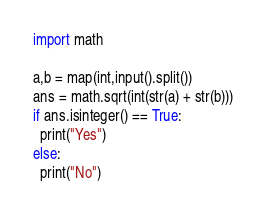<code> <loc_0><loc_0><loc_500><loc_500><_Python_>import math 

a,b = map(int,input().split())
ans = math.sqrt(int(str(a) + str(b)))
if ans.isinteger() == True:
  print("Yes")
else:
  print("No")</code> 